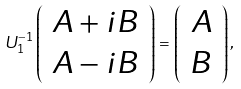Convert formula to latex. <formula><loc_0><loc_0><loc_500><loc_500>U ^ { - 1 } _ { 1 } \left ( \begin{array} { c } A + i B \\ A - i B \end{array} \right ) = \left ( \begin{array} { c } A \\ B \end{array} \right ) ,</formula> 